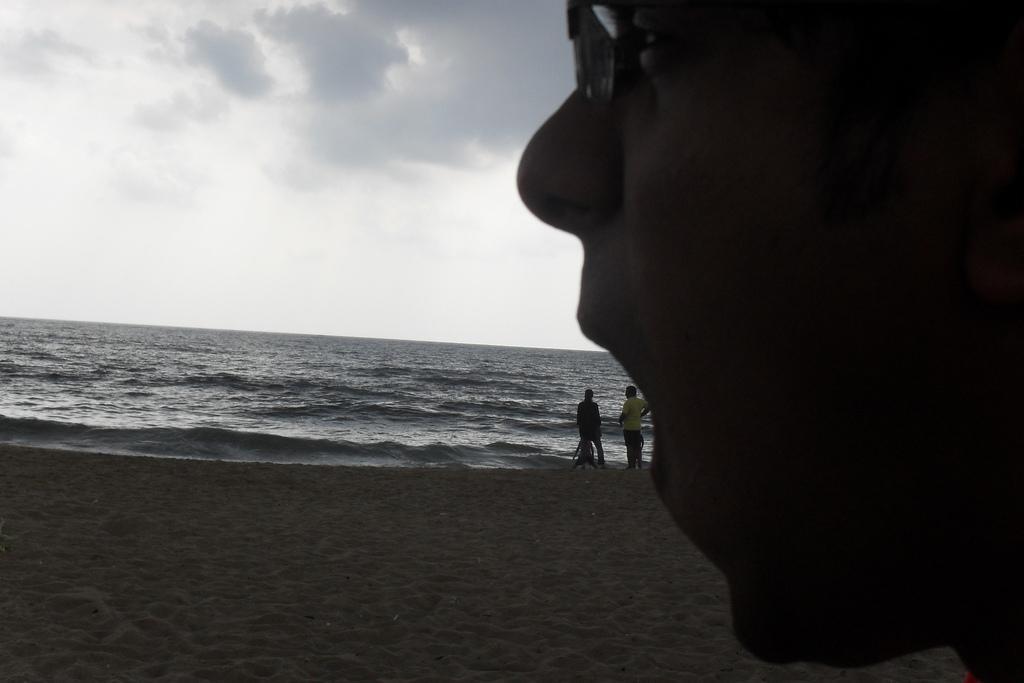Can you describe this image briefly? This is a beach. On the right side, I can see a person's head. At the bottom, I can see the sand. In the background two people are standing and there is an Ocean. At the top of the image I can see the sky and it is cloudy. 